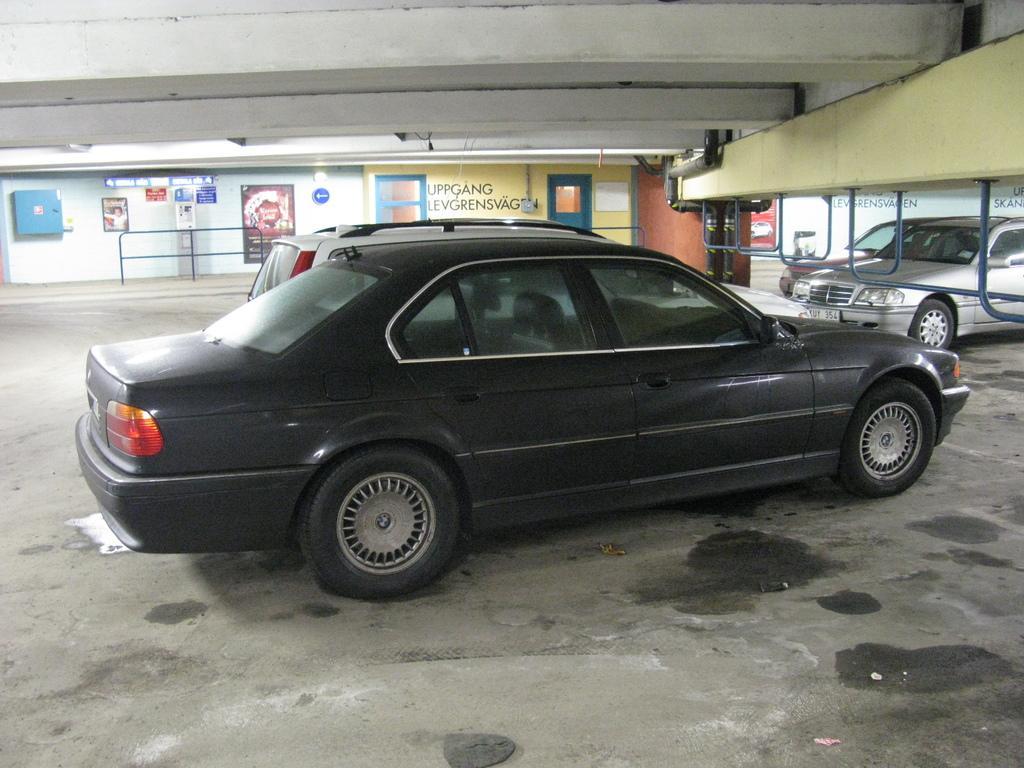Could you give a brief overview of what you see in this image? In this picture we can see some vehicles are parked. At the top of the vehicles there are iron rods and pipes. Behind the vehicles there's a wall with a door, a light, posters and some objects. 